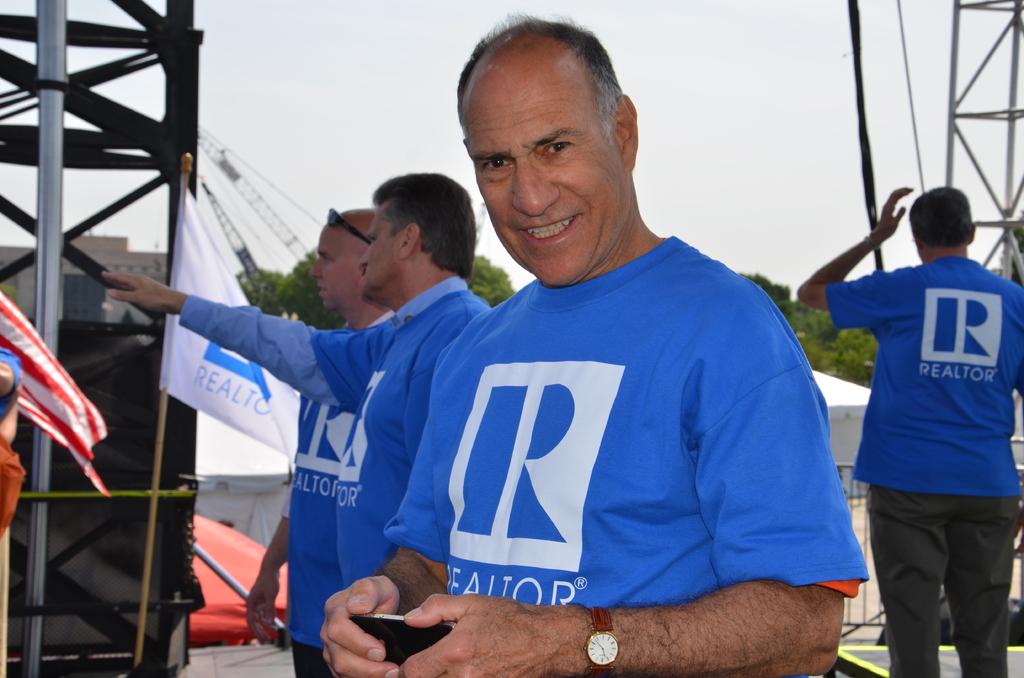What do these people do for a living?
Your response must be concise. Realtor. What lettter is on the shirt?
Your response must be concise. R. 